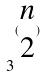Convert formula to latex. <formula><loc_0><loc_0><loc_500><loc_500>3 ^ { ( \begin{matrix} n \\ 2 \end{matrix} ) }</formula> 